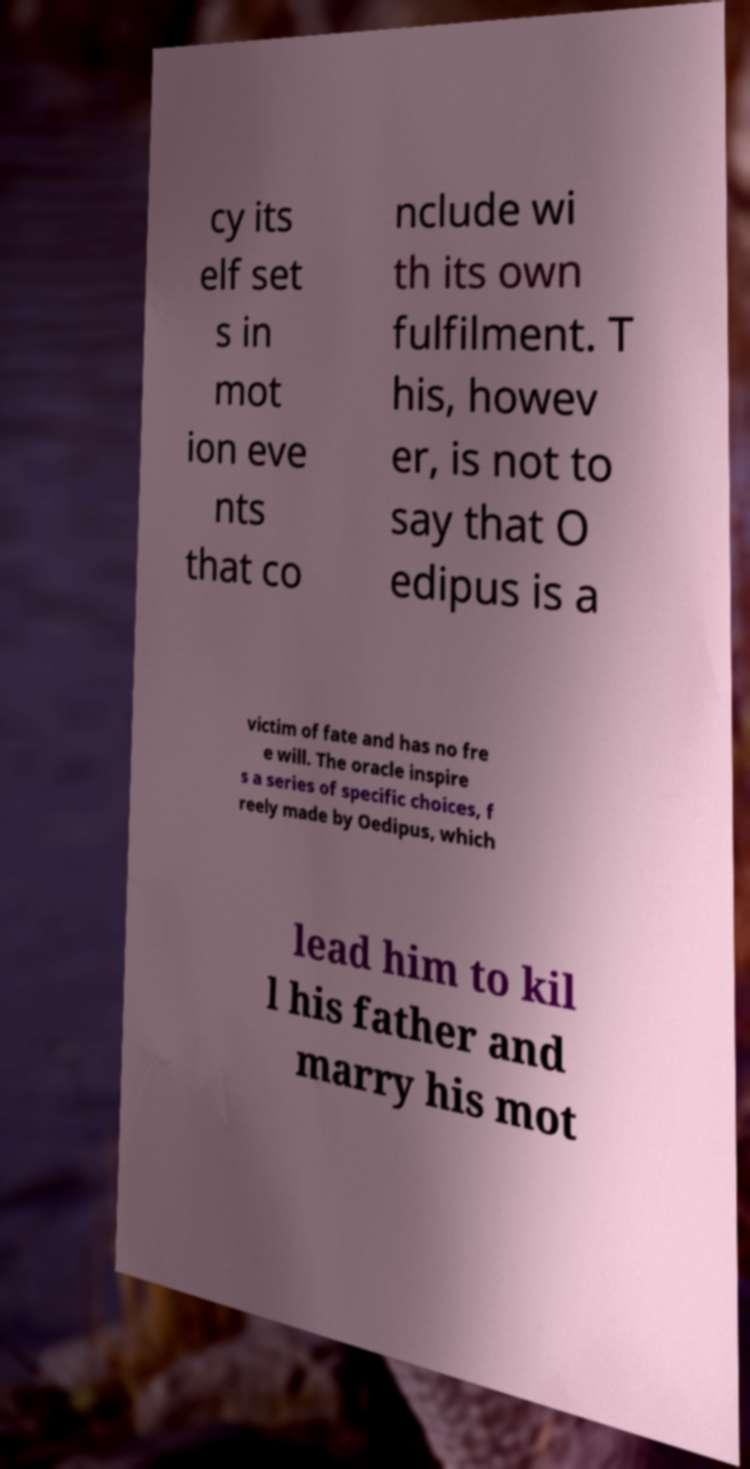Can you accurately transcribe the text from the provided image for me? cy its elf set s in mot ion eve nts that co nclude wi th its own fulfilment. T his, howev er, is not to say that O edipus is a victim of fate and has no fre e will. The oracle inspire s a series of specific choices, f reely made by Oedipus, which lead him to kil l his father and marry his mot 